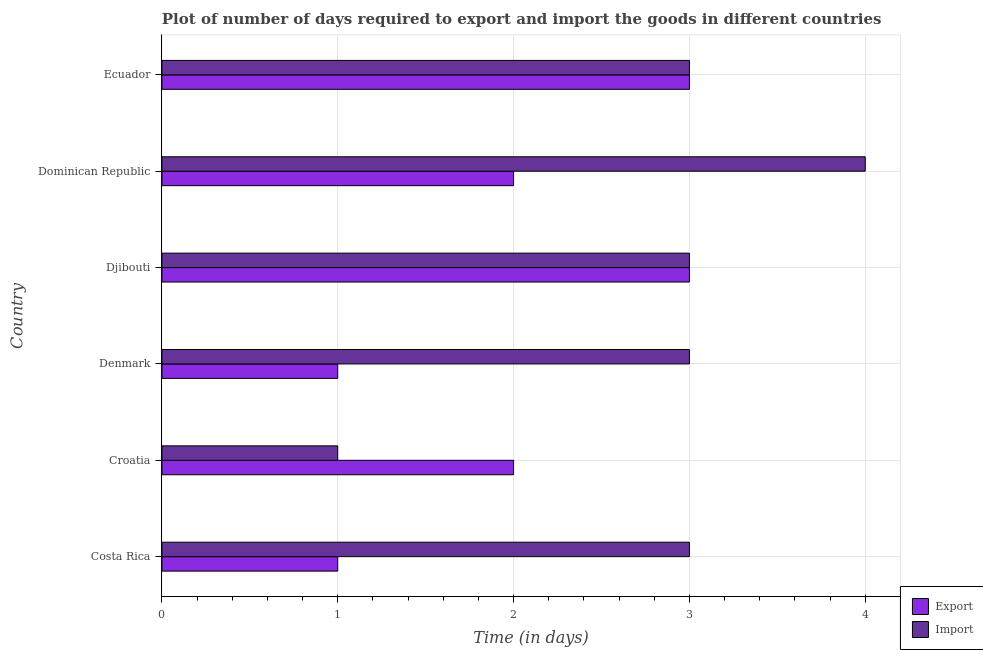How many different coloured bars are there?
Provide a succinct answer. 2. Are the number of bars on each tick of the Y-axis equal?
Keep it short and to the point. Yes. How many bars are there on the 3rd tick from the bottom?
Provide a succinct answer. 2. What is the label of the 1st group of bars from the top?
Ensure brevity in your answer.  Ecuador. What is the time required to export in Djibouti?
Your answer should be compact. 3. In which country was the time required to export maximum?
Provide a short and direct response. Djibouti. In which country was the time required to export minimum?
Ensure brevity in your answer.  Costa Rica. What is the difference between the time required to export in Costa Rica and that in Denmark?
Offer a very short reply. 0. What is the difference between the time required to import in Dominican Republic and the time required to export in Denmark?
Your answer should be very brief. 3. In how many countries, is the time required to import greater than 1.4 days?
Your answer should be compact. 5. Is the difference between the time required to export in Costa Rica and Croatia greater than the difference between the time required to import in Costa Rica and Croatia?
Provide a succinct answer. No. What is the difference between the highest and the second highest time required to export?
Offer a terse response. 0. What is the difference between the highest and the lowest time required to export?
Your response must be concise. 2. In how many countries, is the time required to export greater than the average time required to export taken over all countries?
Provide a short and direct response. 2. Is the sum of the time required to export in Croatia and Ecuador greater than the maximum time required to import across all countries?
Your answer should be very brief. Yes. What does the 1st bar from the top in Costa Rica represents?
Provide a succinct answer. Import. What does the 1st bar from the bottom in Croatia represents?
Offer a terse response. Export. Are all the bars in the graph horizontal?
Your answer should be compact. Yes. How many countries are there in the graph?
Keep it short and to the point. 6. What is the difference between two consecutive major ticks on the X-axis?
Make the answer very short. 1. Does the graph contain any zero values?
Give a very brief answer. No. How many legend labels are there?
Give a very brief answer. 2. What is the title of the graph?
Make the answer very short. Plot of number of days required to export and import the goods in different countries. What is the label or title of the X-axis?
Make the answer very short. Time (in days). What is the Time (in days) in Export in Costa Rica?
Ensure brevity in your answer.  1. What is the Time (in days) of Import in Costa Rica?
Keep it short and to the point. 3. What is the Time (in days) in Export in Croatia?
Make the answer very short. 2. What is the Time (in days) of Import in Croatia?
Offer a terse response. 1. What is the Time (in days) of Export in Djibouti?
Provide a succinct answer. 3. What is the Time (in days) of Export in Dominican Republic?
Ensure brevity in your answer.  2. What is the Time (in days) in Import in Dominican Republic?
Provide a short and direct response. 4. What is the Time (in days) of Export in Ecuador?
Your answer should be very brief. 3. Across all countries, what is the maximum Time (in days) in Import?
Your answer should be very brief. 4. What is the total Time (in days) of Export in the graph?
Your response must be concise. 12. What is the total Time (in days) in Import in the graph?
Give a very brief answer. 17. What is the difference between the Time (in days) in Export in Costa Rica and that in Denmark?
Your answer should be very brief. 0. What is the difference between the Time (in days) in Import in Costa Rica and that in Dominican Republic?
Your response must be concise. -1. What is the difference between the Time (in days) of Export in Costa Rica and that in Ecuador?
Offer a terse response. -2. What is the difference between the Time (in days) of Import in Costa Rica and that in Ecuador?
Your response must be concise. 0. What is the difference between the Time (in days) of Import in Croatia and that in Denmark?
Keep it short and to the point. -2. What is the difference between the Time (in days) of Export in Croatia and that in Dominican Republic?
Your response must be concise. 0. What is the difference between the Time (in days) of Export in Croatia and that in Ecuador?
Your answer should be compact. -1. What is the difference between the Time (in days) in Import in Croatia and that in Ecuador?
Keep it short and to the point. -2. What is the difference between the Time (in days) of Import in Denmark and that in Djibouti?
Give a very brief answer. 0. What is the difference between the Time (in days) of Export in Denmark and that in Dominican Republic?
Provide a short and direct response. -1. What is the difference between the Time (in days) in Import in Denmark and that in Dominican Republic?
Ensure brevity in your answer.  -1. What is the difference between the Time (in days) in Export in Denmark and that in Ecuador?
Your response must be concise. -2. What is the difference between the Time (in days) in Export in Djibouti and that in Ecuador?
Your answer should be compact. 0. What is the difference between the Time (in days) in Export in Costa Rica and the Time (in days) in Import in Croatia?
Give a very brief answer. 0. What is the difference between the Time (in days) of Export in Costa Rica and the Time (in days) of Import in Djibouti?
Give a very brief answer. -2. What is the difference between the Time (in days) of Export in Costa Rica and the Time (in days) of Import in Dominican Republic?
Make the answer very short. -3. What is the difference between the Time (in days) in Export in Costa Rica and the Time (in days) in Import in Ecuador?
Your answer should be compact. -2. What is the difference between the Time (in days) of Export in Croatia and the Time (in days) of Import in Djibouti?
Give a very brief answer. -1. What is the difference between the Time (in days) of Export in Croatia and the Time (in days) of Import in Ecuador?
Your answer should be compact. -1. What is the difference between the Time (in days) of Export in Denmark and the Time (in days) of Import in Djibouti?
Your answer should be compact. -2. What is the difference between the Time (in days) in Export in Denmark and the Time (in days) in Import in Dominican Republic?
Your answer should be very brief. -3. What is the difference between the Time (in days) in Export in Djibouti and the Time (in days) in Import in Dominican Republic?
Keep it short and to the point. -1. What is the average Time (in days) in Export per country?
Make the answer very short. 2. What is the average Time (in days) of Import per country?
Give a very brief answer. 2.83. What is the difference between the Time (in days) in Export and Time (in days) in Import in Costa Rica?
Give a very brief answer. -2. What is the difference between the Time (in days) of Export and Time (in days) of Import in Croatia?
Your answer should be compact. 1. What is the difference between the Time (in days) of Export and Time (in days) of Import in Dominican Republic?
Your answer should be compact. -2. What is the ratio of the Time (in days) of Export in Costa Rica to that in Croatia?
Your response must be concise. 0.5. What is the ratio of the Time (in days) of Export in Costa Rica to that in Denmark?
Offer a terse response. 1. What is the ratio of the Time (in days) of Export in Costa Rica to that in Djibouti?
Offer a very short reply. 0.33. What is the ratio of the Time (in days) of Import in Costa Rica to that in Dominican Republic?
Provide a succinct answer. 0.75. What is the ratio of the Time (in days) in Export in Costa Rica to that in Ecuador?
Provide a short and direct response. 0.33. What is the ratio of the Time (in days) in Import in Croatia to that in Denmark?
Make the answer very short. 0.33. What is the ratio of the Time (in days) in Import in Croatia to that in Djibouti?
Give a very brief answer. 0.33. What is the ratio of the Time (in days) in Import in Croatia to that in Dominican Republic?
Your response must be concise. 0.25. What is the ratio of the Time (in days) of Export in Croatia to that in Ecuador?
Your answer should be compact. 0.67. What is the ratio of the Time (in days) of Import in Croatia to that in Ecuador?
Provide a succinct answer. 0.33. What is the ratio of the Time (in days) of Export in Denmark to that in Djibouti?
Your answer should be very brief. 0.33. What is the ratio of the Time (in days) in Export in Djibouti to that in Dominican Republic?
Your answer should be very brief. 1.5. What is the ratio of the Time (in days) of Export in Dominican Republic to that in Ecuador?
Keep it short and to the point. 0.67. What is the ratio of the Time (in days) in Import in Dominican Republic to that in Ecuador?
Your answer should be very brief. 1.33. What is the difference between the highest and the second highest Time (in days) of Export?
Your answer should be very brief. 0. What is the difference between the highest and the second highest Time (in days) in Import?
Give a very brief answer. 1. What is the difference between the highest and the lowest Time (in days) of Export?
Your answer should be compact. 2. 